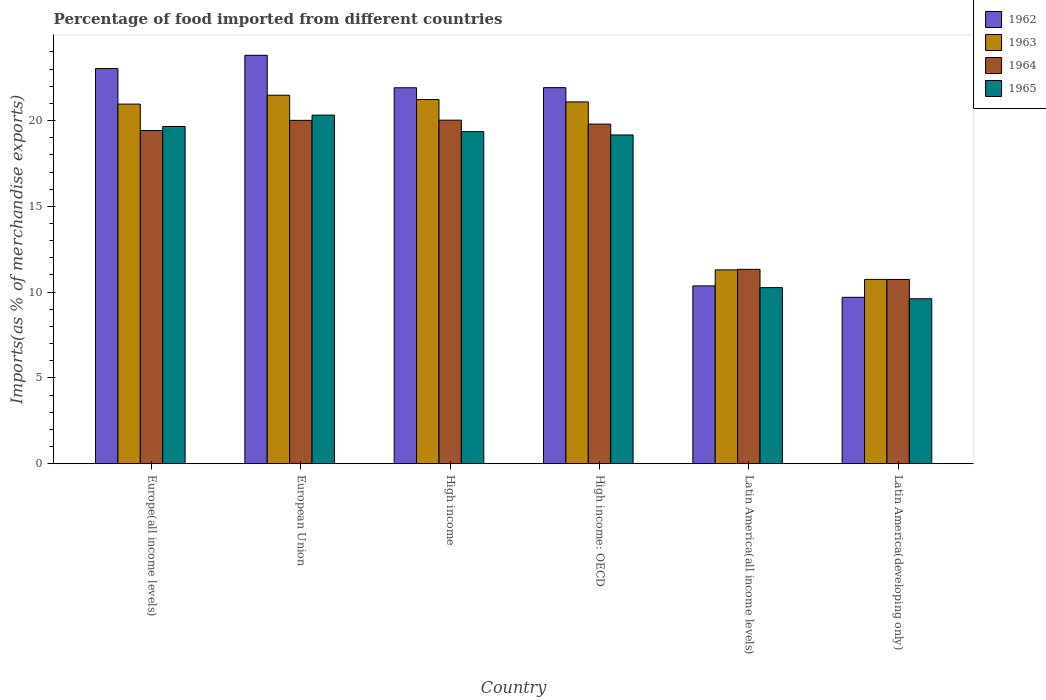How many different coloured bars are there?
Give a very brief answer. 4. How many groups of bars are there?
Offer a terse response. 6. Are the number of bars per tick equal to the number of legend labels?
Your response must be concise. Yes. How many bars are there on the 6th tick from the right?
Your answer should be compact. 4. What is the label of the 4th group of bars from the left?
Your response must be concise. High income: OECD. In how many cases, is the number of bars for a given country not equal to the number of legend labels?
Your answer should be very brief. 0. What is the percentage of imports to different countries in 1965 in Latin America(developing only)?
Offer a very short reply. 9.62. Across all countries, what is the maximum percentage of imports to different countries in 1964?
Ensure brevity in your answer.  20.02. Across all countries, what is the minimum percentage of imports to different countries in 1962?
Keep it short and to the point. 9.7. In which country was the percentage of imports to different countries in 1965 minimum?
Offer a terse response. Latin America(developing only). What is the total percentage of imports to different countries in 1963 in the graph?
Provide a short and direct response. 106.79. What is the difference between the percentage of imports to different countries in 1962 in High income and that in Latin America(developing only)?
Offer a terse response. 12.21. What is the difference between the percentage of imports to different countries in 1964 in European Union and the percentage of imports to different countries in 1963 in High income?
Provide a succinct answer. -1.21. What is the average percentage of imports to different countries in 1965 per country?
Provide a succinct answer. 16.4. What is the difference between the percentage of imports to different countries of/in 1965 and percentage of imports to different countries of/in 1964 in Europe(all income levels)?
Your answer should be compact. 0.24. In how many countries, is the percentage of imports to different countries in 1962 greater than 3 %?
Your answer should be compact. 6. What is the ratio of the percentage of imports to different countries in 1962 in High income to that in High income: OECD?
Keep it short and to the point. 1. Is the difference between the percentage of imports to different countries in 1965 in High income: OECD and Latin America(all income levels) greater than the difference between the percentage of imports to different countries in 1964 in High income: OECD and Latin America(all income levels)?
Give a very brief answer. Yes. What is the difference between the highest and the second highest percentage of imports to different countries in 1965?
Offer a terse response. -0.3. What is the difference between the highest and the lowest percentage of imports to different countries in 1964?
Provide a short and direct response. 9.29. Is the sum of the percentage of imports to different countries in 1965 in European Union and High income greater than the maximum percentage of imports to different countries in 1963 across all countries?
Your answer should be compact. Yes. Is it the case that in every country, the sum of the percentage of imports to different countries in 1963 and percentage of imports to different countries in 1962 is greater than the sum of percentage of imports to different countries in 1965 and percentage of imports to different countries in 1964?
Your response must be concise. No. What does the 1st bar from the left in Latin America(developing only) represents?
Provide a short and direct response. 1962. How many bars are there?
Your answer should be very brief. 24. What is the difference between two consecutive major ticks on the Y-axis?
Ensure brevity in your answer.  5. Are the values on the major ticks of Y-axis written in scientific E-notation?
Offer a very short reply. No. Where does the legend appear in the graph?
Give a very brief answer. Top right. How many legend labels are there?
Your answer should be compact. 4. How are the legend labels stacked?
Offer a very short reply. Vertical. What is the title of the graph?
Your answer should be compact. Percentage of food imported from different countries. Does "1976" appear as one of the legend labels in the graph?
Keep it short and to the point. No. What is the label or title of the X-axis?
Offer a very short reply. Country. What is the label or title of the Y-axis?
Provide a succinct answer. Imports(as % of merchandise exports). What is the Imports(as % of merchandise exports) in 1962 in Europe(all income levels)?
Your answer should be compact. 23.03. What is the Imports(as % of merchandise exports) in 1963 in Europe(all income levels)?
Offer a terse response. 20.96. What is the Imports(as % of merchandise exports) in 1964 in Europe(all income levels)?
Your answer should be compact. 19.42. What is the Imports(as % of merchandise exports) in 1965 in Europe(all income levels)?
Make the answer very short. 19.66. What is the Imports(as % of merchandise exports) of 1962 in European Union?
Provide a succinct answer. 23.8. What is the Imports(as % of merchandise exports) of 1963 in European Union?
Offer a terse response. 21.48. What is the Imports(as % of merchandise exports) in 1964 in European Union?
Provide a succinct answer. 20.01. What is the Imports(as % of merchandise exports) in 1965 in European Union?
Make the answer very short. 20.32. What is the Imports(as % of merchandise exports) of 1962 in High income?
Keep it short and to the point. 21.91. What is the Imports(as % of merchandise exports) in 1963 in High income?
Ensure brevity in your answer.  21.23. What is the Imports(as % of merchandise exports) in 1964 in High income?
Provide a succinct answer. 20.02. What is the Imports(as % of merchandise exports) of 1965 in High income?
Make the answer very short. 19.36. What is the Imports(as % of merchandise exports) of 1962 in High income: OECD?
Offer a very short reply. 21.92. What is the Imports(as % of merchandise exports) of 1963 in High income: OECD?
Ensure brevity in your answer.  21.09. What is the Imports(as % of merchandise exports) in 1964 in High income: OECD?
Make the answer very short. 19.8. What is the Imports(as % of merchandise exports) of 1965 in High income: OECD?
Ensure brevity in your answer.  19.16. What is the Imports(as % of merchandise exports) in 1962 in Latin America(all income levels)?
Provide a succinct answer. 10.36. What is the Imports(as % of merchandise exports) in 1963 in Latin America(all income levels)?
Provide a succinct answer. 11.3. What is the Imports(as % of merchandise exports) of 1964 in Latin America(all income levels)?
Ensure brevity in your answer.  11.33. What is the Imports(as % of merchandise exports) in 1965 in Latin America(all income levels)?
Offer a very short reply. 10.26. What is the Imports(as % of merchandise exports) of 1962 in Latin America(developing only)?
Offer a very short reply. 9.7. What is the Imports(as % of merchandise exports) in 1963 in Latin America(developing only)?
Keep it short and to the point. 10.74. What is the Imports(as % of merchandise exports) of 1964 in Latin America(developing only)?
Make the answer very short. 10.74. What is the Imports(as % of merchandise exports) in 1965 in Latin America(developing only)?
Ensure brevity in your answer.  9.62. Across all countries, what is the maximum Imports(as % of merchandise exports) in 1962?
Your answer should be very brief. 23.8. Across all countries, what is the maximum Imports(as % of merchandise exports) in 1963?
Your answer should be compact. 21.48. Across all countries, what is the maximum Imports(as % of merchandise exports) of 1964?
Your answer should be very brief. 20.02. Across all countries, what is the maximum Imports(as % of merchandise exports) in 1965?
Provide a succinct answer. 20.32. Across all countries, what is the minimum Imports(as % of merchandise exports) of 1962?
Provide a succinct answer. 9.7. Across all countries, what is the minimum Imports(as % of merchandise exports) in 1963?
Offer a very short reply. 10.74. Across all countries, what is the minimum Imports(as % of merchandise exports) in 1964?
Keep it short and to the point. 10.74. Across all countries, what is the minimum Imports(as % of merchandise exports) of 1965?
Offer a terse response. 9.62. What is the total Imports(as % of merchandise exports) in 1962 in the graph?
Ensure brevity in your answer.  110.73. What is the total Imports(as % of merchandise exports) in 1963 in the graph?
Offer a very short reply. 106.79. What is the total Imports(as % of merchandise exports) in 1964 in the graph?
Your response must be concise. 101.32. What is the total Imports(as % of merchandise exports) in 1965 in the graph?
Offer a terse response. 98.37. What is the difference between the Imports(as % of merchandise exports) in 1962 in Europe(all income levels) and that in European Union?
Ensure brevity in your answer.  -0.77. What is the difference between the Imports(as % of merchandise exports) of 1963 in Europe(all income levels) and that in European Union?
Make the answer very short. -0.52. What is the difference between the Imports(as % of merchandise exports) of 1964 in Europe(all income levels) and that in European Union?
Make the answer very short. -0.59. What is the difference between the Imports(as % of merchandise exports) of 1965 in Europe(all income levels) and that in European Union?
Your answer should be very brief. -0.66. What is the difference between the Imports(as % of merchandise exports) in 1962 in Europe(all income levels) and that in High income?
Give a very brief answer. 1.12. What is the difference between the Imports(as % of merchandise exports) in 1963 in Europe(all income levels) and that in High income?
Your answer should be very brief. -0.27. What is the difference between the Imports(as % of merchandise exports) in 1964 in Europe(all income levels) and that in High income?
Offer a terse response. -0.61. What is the difference between the Imports(as % of merchandise exports) in 1965 in Europe(all income levels) and that in High income?
Make the answer very short. 0.3. What is the difference between the Imports(as % of merchandise exports) of 1962 in Europe(all income levels) and that in High income: OECD?
Offer a terse response. 1.11. What is the difference between the Imports(as % of merchandise exports) of 1963 in Europe(all income levels) and that in High income: OECD?
Offer a very short reply. -0.13. What is the difference between the Imports(as % of merchandise exports) of 1964 in Europe(all income levels) and that in High income: OECD?
Offer a terse response. -0.38. What is the difference between the Imports(as % of merchandise exports) in 1965 in Europe(all income levels) and that in High income: OECD?
Ensure brevity in your answer.  0.5. What is the difference between the Imports(as % of merchandise exports) in 1962 in Europe(all income levels) and that in Latin America(all income levels)?
Keep it short and to the point. 12.67. What is the difference between the Imports(as % of merchandise exports) in 1963 in Europe(all income levels) and that in Latin America(all income levels)?
Keep it short and to the point. 9.66. What is the difference between the Imports(as % of merchandise exports) in 1964 in Europe(all income levels) and that in Latin America(all income levels)?
Give a very brief answer. 8.09. What is the difference between the Imports(as % of merchandise exports) of 1965 in Europe(all income levels) and that in Latin America(all income levels)?
Offer a very short reply. 9.39. What is the difference between the Imports(as % of merchandise exports) in 1962 in Europe(all income levels) and that in Latin America(developing only)?
Provide a short and direct response. 13.33. What is the difference between the Imports(as % of merchandise exports) of 1963 in Europe(all income levels) and that in Latin America(developing only)?
Offer a terse response. 10.22. What is the difference between the Imports(as % of merchandise exports) of 1964 in Europe(all income levels) and that in Latin America(developing only)?
Give a very brief answer. 8.68. What is the difference between the Imports(as % of merchandise exports) of 1965 in Europe(all income levels) and that in Latin America(developing only)?
Offer a very short reply. 10.04. What is the difference between the Imports(as % of merchandise exports) of 1962 in European Union and that in High income?
Give a very brief answer. 1.89. What is the difference between the Imports(as % of merchandise exports) of 1963 in European Union and that in High income?
Offer a very short reply. 0.25. What is the difference between the Imports(as % of merchandise exports) in 1964 in European Union and that in High income?
Offer a terse response. -0.01. What is the difference between the Imports(as % of merchandise exports) in 1965 in European Union and that in High income?
Offer a terse response. 0.96. What is the difference between the Imports(as % of merchandise exports) in 1962 in European Union and that in High income: OECD?
Provide a succinct answer. 1.89. What is the difference between the Imports(as % of merchandise exports) of 1963 in European Union and that in High income: OECD?
Give a very brief answer. 0.39. What is the difference between the Imports(as % of merchandise exports) in 1964 in European Union and that in High income: OECD?
Provide a short and direct response. 0.22. What is the difference between the Imports(as % of merchandise exports) of 1965 in European Union and that in High income: OECD?
Give a very brief answer. 1.16. What is the difference between the Imports(as % of merchandise exports) in 1962 in European Union and that in Latin America(all income levels)?
Provide a succinct answer. 13.44. What is the difference between the Imports(as % of merchandise exports) of 1963 in European Union and that in Latin America(all income levels)?
Your answer should be compact. 10.18. What is the difference between the Imports(as % of merchandise exports) of 1964 in European Union and that in Latin America(all income levels)?
Keep it short and to the point. 8.68. What is the difference between the Imports(as % of merchandise exports) in 1965 in European Union and that in Latin America(all income levels)?
Provide a succinct answer. 10.05. What is the difference between the Imports(as % of merchandise exports) in 1962 in European Union and that in Latin America(developing only)?
Make the answer very short. 14.11. What is the difference between the Imports(as % of merchandise exports) in 1963 in European Union and that in Latin America(developing only)?
Your answer should be very brief. 10.73. What is the difference between the Imports(as % of merchandise exports) of 1964 in European Union and that in Latin America(developing only)?
Provide a short and direct response. 9.27. What is the difference between the Imports(as % of merchandise exports) in 1965 in European Union and that in Latin America(developing only)?
Your response must be concise. 10.7. What is the difference between the Imports(as % of merchandise exports) of 1962 in High income and that in High income: OECD?
Keep it short and to the point. -0.01. What is the difference between the Imports(as % of merchandise exports) in 1963 in High income and that in High income: OECD?
Your response must be concise. 0.14. What is the difference between the Imports(as % of merchandise exports) in 1964 in High income and that in High income: OECD?
Keep it short and to the point. 0.23. What is the difference between the Imports(as % of merchandise exports) of 1965 in High income and that in High income: OECD?
Make the answer very short. 0.19. What is the difference between the Imports(as % of merchandise exports) in 1962 in High income and that in Latin America(all income levels)?
Ensure brevity in your answer.  11.55. What is the difference between the Imports(as % of merchandise exports) in 1963 in High income and that in Latin America(all income levels)?
Give a very brief answer. 9.93. What is the difference between the Imports(as % of merchandise exports) of 1964 in High income and that in Latin America(all income levels)?
Keep it short and to the point. 8.7. What is the difference between the Imports(as % of merchandise exports) of 1965 in High income and that in Latin America(all income levels)?
Provide a succinct answer. 9.09. What is the difference between the Imports(as % of merchandise exports) in 1962 in High income and that in Latin America(developing only)?
Offer a very short reply. 12.21. What is the difference between the Imports(as % of merchandise exports) in 1963 in High income and that in Latin America(developing only)?
Provide a short and direct response. 10.48. What is the difference between the Imports(as % of merchandise exports) in 1964 in High income and that in Latin America(developing only)?
Offer a very short reply. 9.29. What is the difference between the Imports(as % of merchandise exports) in 1965 in High income and that in Latin America(developing only)?
Your answer should be compact. 9.74. What is the difference between the Imports(as % of merchandise exports) of 1962 in High income: OECD and that in Latin America(all income levels)?
Your response must be concise. 11.55. What is the difference between the Imports(as % of merchandise exports) of 1963 in High income: OECD and that in Latin America(all income levels)?
Offer a terse response. 9.79. What is the difference between the Imports(as % of merchandise exports) in 1964 in High income: OECD and that in Latin America(all income levels)?
Keep it short and to the point. 8.47. What is the difference between the Imports(as % of merchandise exports) in 1965 in High income: OECD and that in Latin America(all income levels)?
Your answer should be very brief. 8.9. What is the difference between the Imports(as % of merchandise exports) in 1962 in High income: OECD and that in Latin America(developing only)?
Make the answer very short. 12.22. What is the difference between the Imports(as % of merchandise exports) in 1963 in High income: OECD and that in Latin America(developing only)?
Your answer should be very brief. 10.34. What is the difference between the Imports(as % of merchandise exports) of 1964 in High income: OECD and that in Latin America(developing only)?
Provide a succinct answer. 9.06. What is the difference between the Imports(as % of merchandise exports) in 1965 in High income: OECD and that in Latin America(developing only)?
Provide a succinct answer. 9.54. What is the difference between the Imports(as % of merchandise exports) of 1962 in Latin America(all income levels) and that in Latin America(developing only)?
Give a very brief answer. 0.67. What is the difference between the Imports(as % of merchandise exports) of 1963 in Latin America(all income levels) and that in Latin America(developing only)?
Provide a short and direct response. 0.56. What is the difference between the Imports(as % of merchandise exports) of 1964 in Latin America(all income levels) and that in Latin America(developing only)?
Ensure brevity in your answer.  0.59. What is the difference between the Imports(as % of merchandise exports) of 1965 in Latin America(all income levels) and that in Latin America(developing only)?
Your response must be concise. 0.65. What is the difference between the Imports(as % of merchandise exports) in 1962 in Europe(all income levels) and the Imports(as % of merchandise exports) in 1963 in European Union?
Give a very brief answer. 1.55. What is the difference between the Imports(as % of merchandise exports) in 1962 in Europe(all income levels) and the Imports(as % of merchandise exports) in 1964 in European Union?
Make the answer very short. 3.02. What is the difference between the Imports(as % of merchandise exports) of 1962 in Europe(all income levels) and the Imports(as % of merchandise exports) of 1965 in European Union?
Your answer should be very brief. 2.71. What is the difference between the Imports(as % of merchandise exports) in 1963 in Europe(all income levels) and the Imports(as % of merchandise exports) in 1964 in European Union?
Your answer should be very brief. 0.95. What is the difference between the Imports(as % of merchandise exports) of 1963 in Europe(all income levels) and the Imports(as % of merchandise exports) of 1965 in European Union?
Ensure brevity in your answer.  0.64. What is the difference between the Imports(as % of merchandise exports) in 1964 in Europe(all income levels) and the Imports(as % of merchandise exports) in 1965 in European Union?
Make the answer very short. -0.9. What is the difference between the Imports(as % of merchandise exports) of 1962 in Europe(all income levels) and the Imports(as % of merchandise exports) of 1963 in High income?
Offer a terse response. 1.81. What is the difference between the Imports(as % of merchandise exports) of 1962 in Europe(all income levels) and the Imports(as % of merchandise exports) of 1964 in High income?
Keep it short and to the point. 3.01. What is the difference between the Imports(as % of merchandise exports) of 1962 in Europe(all income levels) and the Imports(as % of merchandise exports) of 1965 in High income?
Provide a short and direct response. 3.68. What is the difference between the Imports(as % of merchandise exports) of 1963 in Europe(all income levels) and the Imports(as % of merchandise exports) of 1964 in High income?
Your response must be concise. 0.94. What is the difference between the Imports(as % of merchandise exports) of 1963 in Europe(all income levels) and the Imports(as % of merchandise exports) of 1965 in High income?
Make the answer very short. 1.61. What is the difference between the Imports(as % of merchandise exports) in 1964 in Europe(all income levels) and the Imports(as % of merchandise exports) in 1965 in High income?
Provide a succinct answer. 0.06. What is the difference between the Imports(as % of merchandise exports) in 1962 in Europe(all income levels) and the Imports(as % of merchandise exports) in 1963 in High income: OECD?
Ensure brevity in your answer.  1.94. What is the difference between the Imports(as % of merchandise exports) of 1962 in Europe(all income levels) and the Imports(as % of merchandise exports) of 1964 in High income: OECD?
Offer a very short reply. 3.24. What is the difference between the Imports(as % of merchandise exports) of 1962 in Europe(all income levels) and the Imports(as % of merchandise exports) of 1965 in High income: OECD?
Give a very brief answer. 3.87. What is the difference between the Imports(as % of merchandise exports) in 1963 in Europe(all income levels) and the Imports(as % of merchandise exports) in 1964 in High income: OECD?
Your answer should be very brief. 1.16. What is the difference between the Imports(as % of merchandise exports) in 1963 in Europe(all income levels) and the Imports(as % of merchandise exports) in 1965 in High income: OECD?
Your answer should be very brief. 1.8. What is the difference between the Imports(as % of merchandise exports) in 1964 in Europe(all income levels) and the Imports(as % of merchandise exports) in 1965 in High income: OECD?
Ensure brevity in your answer.  0.26. What is the difference between the Imports(as % of merchandise exports) in 1962 in Europe(all income levels) and the Imports(as % of merchandise exports) in 1963 in Latin America(all income levels)?
Ensure brevity in your answer.  11.73. What is the difference between the Imports(as % of merchandise exports) in 1962 in Europe(all income levels) and the Imports(as % of merchandise exports) in 1964 in Latin America(all income levels)?
Your answer should be very brief. 11.7. What is the difference between the Imports(as % of merchandise exports) of 1962 in Europe(all income levels) and the Imports(as % of merchandise exports) of 1965 in Latin America(all income levels)?
Provide a succinct answer. 12.77. What is the difference between the Imports(as % of merchandise exports) in 1963 in Europe(all income levels) and the Imports(as % of merchandise exports) in 1964 in Latin America(all income levels)?
Provide a succinct answer. 9.63. What is the difference between the Imports(as % of merchandise exports) in 1963 in Europe(all income levels) and the Imports(as % of merchandise exports) in 1965 in Latin America(all income levels)?
Give a very brief answer. 10.7. What is the difference between the Imports(as % of merchandise exports) in 1964 in Europe(all income levels) and the Imports(as % of merchandise exports) in 1965 in Latin America(all income levels)?
Your response must be concise. 9.15. What is the difference between the Imports(as % of merchandise exports) in 1962 in Europe(all income levels) and the Imports(as % of merchandise exports) in 1963 in Latin America(developing only)?
Offer a very short reply. 12.29. What is the difference between the Imports(as % of merchandise exports) of 1962 in Europe(all income levels) and the Imports(as % of merchandise exports) of 1964 in Latin America(developing only)?
Provide a short and direct response. 12.29. What is the difference between the Imports(as % of merchandise exports) in 1962 in Europe(all income levels) and the Imports(as % of merchandise exports) in 1965 in Latin America(developing only)?
Your answer should be compact. 13.41. What is the difference between the Imports(as % of merchandise exports) of 1963 in Europe(all income levels) and the Imports(as % of merchandise exports) of 1964 in Latin America(developing only)?
Offer a terse response. 10.22. What is the difference between the Imports(as % of merchandise exports) in 1963 in Europe(all income levels) and the Imports(as % of merchandise exports) in 1965 in Latin America(developing only)?
Your answer should be very brief. 11.34. What is the difference between the Imports(as % of merchandise exports) of 1964 in Europe(all income levels) and the Imports(as % of merchandise exports) of 1965 in Latin America(developing only)?
Your response must be concise. 9.8. What is the difference between the Imports(as % of merchandise exports) in 1962 in European Union and the Imports(as % of merchandise exports) in 1963 in High income?
Your answer should be compact. 2.58. What is the difference between the Imports(as % of merchandise exports) of 1962 in European Union and the Imports(as % of merchandise exports) of 1964 in High income?
Offer a terse response. 3.78. What is the difference between the Imports(as % of merchandise exports) of 1962 in European Union and the Imports(as % of merchandise exports) of 1965 in High income?
Offer a very short reply. 4.45. What is the difference between the Imports(as % of merchandise exports) in 1963 in European Union and the Imports(as % of merchandise exports) in 1964 in High income?
Your response must be concise. 1.45. What is the difference between the Imports(as % of merchandise exports) of 1963 in European Union and the Imports(as % of merchandise exports) of 1965 in High income?
Offer a very short reply. 2.12. What is the difference between the Imports(as % of merchandise exports) of 1964 in European Union and the Imports(as % of merchandise exports) of 1965 in High income?
Offer a very short reply. 0.66. What is the difference between the Imports(as % of merchandise exports) in 1962 in European Union and the Imports(as % of merchandise exports) in 1963 in High income: OECD?
Your answer should be compact. 2.72. What is the difference between the Imports(as % of merchandise exports) of 1962 in European Union and the Imports(as % of merchandise exports) of 1964 in High income: OECD?
Offer a terse response. 4.01. What is the difference between the Imports(as % of merchandise exports) in 1962 in European Union and the Imports(as % of merchandise exports) in 1965 in High income: OECD?
Provide a short and direct response. 4.64. What is the difference between the Imports(as % of merchandise exports) of 1963 in European Union and the Imports(as % of merchandise exports) of 1964 in High income: OECD?
Offer a very short reply. 1.68. What is the difference between the Imports(as % of merchandise exports) of 1963 in European Union and the Imports(as % of merchandise exports) of 1965 in High income: OECD?
Provide a succinct answer. 2.32. What is the difference between the Imports(as % of merchandise exports) of 1964 in European Union and the Imports(as % of merchandise exports) of 1965 in High income: OECD?
Your response must be concise. 0.85. What is the difference between the Imports(as % of merchandise exports) of 1962 in European Union and the Imports(as % of merchandise exports) of 1963 in Latin America(all income levels)?
Ensure brevity in your answer.  12.51. What is the difference between the Imports(as % of merchandise exports) in 1962 in European Union and the Imports(as % of merchandise exports) in 1964 in Latin America(all income levels)?
Provide a succinct answer. 12.47. What is the difference between the Imports(as % of merchandise exports) in 1962 in European Union and the Imports(as % of merchandise exports) in 1965 in Latin America(all income levels)?
Your answer should be compact. 13.54. What is the difference between the Imports(as % of merchandise exports) of 1963 in European Union and the Imports(as % of merchandise exports) of 1964 in Latin America(all income levels)?
Keep it short and to the point. 10.15. What is the difference between the Imports(as % of merchandise exports) in 1963 in European Union and the Imports(as % of merchandise exports) in 1965 in Latin America(all income levels)?
Your response must be concise. 11.21. What is the difference between the Imports(as % of merchandise exports) in 1964 in European Union and the Imports(as % of merchandise exports) in 1965 in Latin America(all income levels)?
Offer a terse response. 9.75. What is the difference between the Imports(as % of merchandise exports) of 1962 in European Union and the Imports(as % of merchandise exports) of 1963 in Latin America(developing only)?
Make the answer very short. 13.06. What is the difference between the Imports(as % of merchandise exports) of 1962 in European Union and the Imports(as % of merchandise exports) of 1964 in Latin America(developing only)?
Keep it short and to the point. 13.06. What is the difference between the Imports(as % of merchandise exports) in 1962 in European Union and the Imports(as % of merchandise exports) in 1965 in Latin America(developing only)?
Make the answer very short. 14.19. What is the difference between the Imports(as % of merchandise exports) in 1963 in European Union and the Imports(as % of merchandise exports) in 1964 in Latin America(developing only)?
Your answer should be very brief. 10.74. What is the difference between the Imports(as % of merchandise exports) in 1963 in European Union and the Imports(as % of merchandise exports) in 1965 in Latin America(developing only)?
Your response must be concise. 11.86. What is the difference between the Imports(as % of merchandise exports) in 1964 in European Union and the Imports(as % of merchandise exports) in 1965 in Latin America(developing only)?
Give a very brief answer. 10.39. What is the difference between the Imports(as % of merchandise exports) of 1962 in High income and the Imports(as % of merchandise exports) of 1963 in High income: OECD?
Your answer should be compact. 0.83. What is the difference between the Imports(as % of merchandise exports) in 1962 in High income and the Imports(as % of merchandise exports) in 1964 in High income: OECD?
Ensure brevity in your answer.  2.12. What is the difference between the Imports(as % of merchandise exports) in 1962 in High income and the Imports(as % of merchandise exports) in 1965 in High income: OECD?
Give a very brief answer. 2.75. What is the difference between the Imports(as % of merchandise exports) in 1963 in High income and the Imports(as % of merchandise exports) in 1964 in High income: OECD?
Your answer should be compact. 1.43. What is the difference between the Imports(as % of merchandise exports) of 1963 in High income and the Imports(as % of merchandise exports) of 1965 in High income: OECD?
Your answer should be compact. 2.06. What is the difference between the Imports(as % of merchandise exports) in 1964 in High income and the Imports(as % of merchandise exports) in 1965 in High income: OECD?
Keep it short and to the point. 0.86. What is the difference between the Imports(as % of merchandise exports) of 1962 in High income and the Imports(as % of merchandise exports) of 1963 in Latin America(all income levels)?
Ensure brevity in your answer.  10.61. What is the difference between the Imports(as % of merchandise exports) in 1962 in High income and the Imports(as % of merchandise exports) in 1964 in Latin America(all income levels)?
Keep it short and to the point. 10.58. What is the difference between the Imports(as % of merchandise exports) of 1962 in High income and the Imports(as % of merchandise exports) of 1965 in Latin America(all income levels)?
Ensure brevity in your answer.  11.65. What is the difference between the Imports(as % of merchandise exports) of 1963 in High income and the Imports(as % of merchandise exports) of 1964 in Latin America(all income levels)?
Offer a terse response. 9.9. What is the difference between the Imports(as % of merchandise exports) of 1963 in High income and the Imports(as % of merchandise exports) of 1965 in Latin America(all income levels)?
Provide a succinct answer. 10.96. What is the difference between the Imports(as % of merchandise exports) of 1964 in High income and the Imports(as % of merchandise exports) of 1965 in Latin America(all income levels)?
Provide a short and direct response. 9.76. What is the difference between the Imports(as % of merchandise exports) of 1962 in High income and the Imports(as % of merchandise exports) of 1963 in Latin America(developing only)?
Give a very brief answer. 11.17. What is the difference between the Imports(as % of merchandise exports) in 1962 in High income and the Imports(as % of merchandise exports) in 1964 in Latin America(developing only)?
Your response must be concise. 11.17. What is the difference between the Imports(as % of merchandise exports) of 1962 in High income and the Imports(as % of merchandise exports) of 1965 in Latin America(developing only)?
Offer a terse response. 12.3. What is the difference between the Imports(as % of merchandise exports) in 1963 in High income and the Imports(as % of merchandise exports) in 1964 in Latin America(developing only)?
Provide a succinct answer. 10.49. What is the difference between the Imports(as % of merchandise exports) of 1963 in High income and the Imports(as % of merchandise exports) of 1965 in Latin America(developing only)?
Your answer should be compact. 11.61. What is the difference between the Imports(as % of merchandise exports) of 1964 in High income and the Imports(as % of merchandise exports) of 1965 in Latin America(developing only)?
Give a very brief answer. 10.41. What is the difference between the Imports(as % of merchandise exports) of 1962 in High income: OECD and the Imports(as % of merchandise exports) of 1963 in Latin America(all income levels)?
Keep it short and to the point. 10.62. What is the difference between the Imports(as % of merchandise exports) of 1962 in High income: OECD and the Imports(as % of merchandise exports) of 1964 in Latin America(all income levels)?
Ensure brevity in your answer.  10.59. What is the difference between the Imports(as % of merchandise exports) in 1962 in High income: OECD and the Imports(as % of merchandise exports) in 1965 in Latin America(all income levels)?
Provide a succinct answer. 11.65. What is the difference between the Imports(as % of merchandise exports) in 1963 in High income: OECD and the Imports(as % of merchandise exports) in 1964 in Latin America(all income levels)?
Offer a terse response. 9.76. What is the difference between the Imports(as % of merchandise exports) of 1963 in High income: OECD and the Imports(as % of merchandise exports) of 1965 in Latin America(all income levels)?
Your response must be concise. 10.82. What is the difference between the Imports(as % of merchandise exports) of 1964 in High income: OECD and the Imports(as % of merchandise exports) of 1965 in Latin America(all income levels)?
Offer a very short reply. 9.53. What is the difference between the Imports(as % of merchandise exports) of 1962 in High income: OECD and the Imports(as % of merchandise exports) of 1963 in Latin America(developing only)?
Keep it short and to the point. 11.18. What is the difference between the Imports(as % of merchandise exports) of 1962 in High income: OECD and the Imports(as % of merchandise exports) of 1964 in Latin America(developing only)?
Your answer should be compact. 11.18. What is the difference between the Imports(as % of merchandise exports) in 1962 in High income: OECD and the Imports(as % of merchandise exports) in 1965 in Latin America(developing only)?
Your answer should be very brief. 12.3. What is the difference between the Imports(as % of merchandise exports) in 1963 in High income: OECD and the Imports(as % of merchandise exports) in 1964 in Latin America(developing only)?
Offer a terse response. 10.35. What is the difference between the Imports(as % of merchandise exports) in 1963 in High income: OECD and the Imports(as % of merchandise exports) in 1965 in Latin America(developing only)?
Provide a short and direct response. 11.47. What is the difference between the Imports(as % of merchandise exports) of 1964 in High income: OECD and the Imports(as % of merchandise exports) of 1965 in Latin America(developing only)?
Offer a very short reply. 10.18. What is the difference between the Imports(as % of merchandise exports) of 1962 in Latin America(all income levels) and the Imports(as % of merchandise exports) of 1963 in Latin America(developing only)?
Your answer should be compact. -0.38. What is the difference between the Imports(as % of merchandise exports) of 1962 in Latin America(all income levels) and the Imports(as % of merchandise exports) of 1964 in Latin America(developing only)?
Your answer should be compact. -0.37. What is the difference between the Imports(as % of merchandise exports) in 1962 in Latin America(all income levels) and the Imports(as % of merchandise exports) in 1965 in Latin America(developing only)?
Your answer should be compact. 0.75. What is the difference between the Imports(as % of merchandise exports) in 1963 in Latin America(all income levels) and the Imports(as % of merchandise exports) in 1964 in Latin America(developing only)?
Give a very brief answer. 0.56. What is the difference between the Imports(as % of merchandise exports) of 1963 in Latin America(all income levels) and the Imports(as % of merchandise exports) of 1965 in Latin America(developing only)?
Provide a succinct answer. 1.68. What is the difference between the Imports(as % of merchandise exports) of 1964 in Latin America(all income levels) and the Imports(as % of merchandise exports) of 1965 in Latin America(developing only)?
Give a very brief answer. 1.71. What is the average Imports(as % of merchandise exports) in 1962 per country?
Your answer should be compact. 18.45. What is the average Imports(as % of merchandise exports) in 1963 per country?
Your answer should be very brief. 17.8. What is the average Imports(as % of merchandise exports) of 1964 per country?
Your response must be concise. 16.89. What is the average Imports(as % of merchandise exports) of 1965 per country?
Ensure brevity in your answer.  16.4. What is the difference between the Imports(as % of merchandise exports) of 1962 and Imports(as % of merchandise exports) of 1963 in Europe(all income levels)?
Keep it short and to the point. 2.07. What is the difference between the Imports(as % of merchandise exports) of 1962 and Imports(as % of merchandise exports) of 1964 in Europe(all income levels)?
Offer a terse response. 3.61. What is the difference between the Imports(as % of merchandise exports) in 1962 and Imports(as % of merchandise exports) in 1965 in Europe(all income levels)?
Your answer should be very brief. 3.37. What is the difference between the Imports(as % of merchandise exports) of 1963 and Imports(as % of merchandise exports) of 1964 in Europe(all income levels)?
Your response must be concise. 1.54. What is the difference between the Imports(as % of merchandise exports) of 1963 and Imports(as % of merchandise exports) of 1965 in Europe(all income levels)?
Your answer should be very brief. 1.3. What is the difference between the Imports(as % of merchandise exports) in 1964 and Imports(as % of merchandise exports) in 1965 in Europe(all income levels)?
Your answer should be very brief. -0.24. What is the difference between the Imports(as % of merchandise exports) in 1962 and Imports(as % of merchandise exports) in 1963 in European Union?
Give a very brief answer. 2.33. What is the difference between the Imports(as % of merchandise exports) of 1962 and Imports(as % of merchandise exports) of 1964 in European Union?
Your answer should be very brief. 3.79. What is the difference between the Imports(as % of merchandise exports) in 1962 and Imports(as % of merchandise exports) in 1965 in European Union?
Provide a short and direct response. 3.49. What is the difference between the Imports(as % of merchandise exports) of 1963 and Imports(as % of merchandise exports) of 1964 in European Union?
Ensure brevity in your answer.  1.46. What is the difference between the Imports(as % of merchandise exports) in 1963 and Imports(as % of merchandise exports) in 1965 in European Union?
Make the answer very short. 1.16. What is the difference between the Imports(as % of merchandise exports) in 1964 and Imports(as % of merchandise exports) in 1965 in European Union?
Offer a very short reply. -0.31. What is the difference between the Imports(as % of merchandise exports) of 1962 and Imports(as % of merchandise exports) of 1963 in High income?
Your answer should be very brief. 0.69. What is the difference between the Imports(as % of merchandise exports) in 1962 and Imports(as % of merchandise exports) in 1964 in High income?
Provide a succinct answer. 1.89. What is the difference between the Imports(as % of merchandise exports) in 1962 and Imports(as % of merchandise exports) in 1965 in High income?
Offer a very short reply. 2.56. What is the difference between the Imports(as % of merchandise exports) in 1963 and Imports(as % of merchandise exports) in 1964 in High income?
Give a very brief answer. 1.2. What is the difference between the Imports(as % of merchandise exports) in 1963 and Imports(as % of merchandise exports) in 1965 in High income?
Your response must be concise. 1.87. What is the difference between the Imports(as % of merchandise exports) in 1964 and Imports(as % of merchandise exports) in 1965 in High income?
Your answer should be very brief. 0.67. What is the difference between the Imports(as % of merchandise exports) of 1962 and Imports(as % of merchandise exports) of 1963 in High income: OECD?
Provide a short and direct response. 0.83. What is the difference between the Imports(as % of merchandise exports) in 1962 and Imports(as % of merchandise exports) in 1964 in High income: OECD?
Ensure brevity in your answer.  2.12. What is the difference between the Imports(as % of merchandise exports) in 1962 and Imports(as % of merchandise exports) in 1965 in High income: OECD?
Your answer should be very brief. 2.76. What is the difference between the Imports(as % of merchandise exports) in 1963 and Imports(as % of merchandise exports) in 1964 in High income: OECD?
Make the answer very short. 1.29. What is the difference between the Imports(as % of merchandise exports) in 1963 and Imports(as % of merchandise exports) in 1965 in High income: OECD?
Your response must be concise. 1.93. What is the difference between the Imports(as % of merchandise exports) in 1964 and Imports(as % of merchandise exports) in 1965 in High income: OECD?
Your answer should be very brief. 0.63. What is the difference between the Imports(as % of merchandise exports) in 1962 and Imports(as % of merchandise exports) in 1963 in Latin America(all income levels)?
Keep it short and to the point. -0.93. What is the difference between the Imports(as % of merchandise exports) in 1962 and Imports(as % of merchandise exports) in 1964 in Latin America(all income levels)?
Make the answer very short. -0.96. What is the difference between the Imports(as % of merchandise exports) of 1962 and Imports(as % of merchandise exports) of 1965 in Latin America(all income levels)?
Give a very brief answer. 0.1. What is the difference between the Imports(as % of merchandise exports) of 1963 and Imports(as % of merchandise exports) of 1964 in Latin America(all income levels)?
Your answer should be compact. -0.03. What is the difference between the Imports(as % of merchandise exports) of 1963 and Imports(as % of merchandise exports) of 1965 in Latin America(all income levels)?
Your answer should be very brief. 1.03. What is the difference between the Imports(as % of merchandise exports) of 1964 and Imports(as % of merchandise exports) of 1965 in Latin America(all income levels)?
Ensure brevity in your answer.  1.07. What is the difference between the Imports(as % of merchandise exports) in 1962 and Imports(as % of merchandise exports) in 1963 in Latin America(developing only)?
Your response must be concise. -1.05. What is the difference between the Imports(as % of merchandise exports) of 1962 and Imports(as % of merchandise exports) of 1964 in Latin America(developing only)?
Provide a succinct answer. -1.04. What is the difference between the Imports(as % of merchandise exports) in 1962 and Imports(as % of merchandise exports) in 1965 in Latin America(developing only)?
Keep it short and to the point. 0.08. What is the difference between the Imports(as % of merchandise exports) in 1963 and Imports(as % of merchandise exports) in 1964 in Latin America(developing only)?
Your answer should be very brief. 0. What is the difference between the Imports(as % of merchandise exports) in 1963 and Imports(as % of merchandise exports) in 1965 in Latin America(developing only)?
Your response must be concise. 1.13. What is the difference between the Imports(as % of merchandise exports) of 1964 and Imports(as % of merchandise exports) of 1965 in Latin America(developing only)?
Provide a short and direct response. 1.12. What is the ratio of the Imports(as % of merchandise exports) in 1962 in Europe(all income levels) to that in European Union?
Keep it short and to the point. 0.97. What is the ratio of the Imports(as % of merchandise exports) in 1963 in Europe(all income levels) to that in European Union?
Provide a succinct answer. 0.98. What is the ratio of the Imports(as % of merchandise exports) of 1964 in Europe(all income levels) to that in European Union?
Provide a short and direct response. 0.97. What is the ratio of the Imports(as % of merchandise exports) in 1965 in Europe(all income levels) to that in European Union?
Your answer should be compact. 0.97. What is the ratio of the Imports(as % of merchandise exports) in 1962 in Europe(all income levels) to that in High income?
Offer a terse response. 1.05. What is the ratio of the Imports(as % of merchandise exports) in 1963 in Europe(all income levels) to that in High income?
Keep it short and to the point. 0.99. What is the ratio of the Imports(as % of merchandise exports) in 1964 in Europe(all income levels) to that in High income?
Your response must be concise. 0.97. What is the ratio of the Imports(as % of merchandise exports) in 1965 in Europe(all income levels) to that in High income?
Give a very brief answer. 1.02. What is the ratio of the Imports(as % of merchandise exports) in 1962 in Europe(all income levels) to that in High income: OECD?
Your answer should be compact. 1.05. What is the ratio of the Imports(as % of merchandise exports) in 1965 in Europe(all income levels) to that in High income: OECD?
Provide a short and direct response. 1.03. What is the ratio of the Imports(as % of merchandise exports) of 1962 in Europe(all income levels) to that in Latin America(all income levels)?
Your answer should be compact. 2.22. What is the ratio of the Imports(as % of merchandise exports) of 1963 in Europe(all income levels) to that in Latin America(all income levels)?
Give a very brief answer. 1.86. What is the ratio of the Imports(as % of merchandise exports) of 1964 in Europe(all income levels) to that in Latin America(all income levels)?
Your answer should be very brief. 1.71. What is the ratio of the Imports(as % of merchandise exports) in 1965 in Europe(all income levels) to that in Latin America(all income levels)?
Provide a succinct answer. 1.92. What is the ratio of the Imports(as % of merchandise exports) of 1962 in Europe(all income levels) to that in Latin America(developing only)?
Give a very brief answer. 2.37. What is the ratio of the Imports(as % of merchandise exports) in 1963 in Europe(all income levels) to that in Latin America(developing only)?
Offer a very short reply. 1.95. What is the ratio of the Imports(as % of merchandise exports) of 1964 in Europe(all income levels) to that in Latin America(developing only)?
Offer a very short reply. 1.81. What is the ratio of the Imports(as % of merchandise exports) of 1965 in Europe(all income levels) to that in Latin America(developing only)?
Your answer should be very brief. 2.04. What is the ratio of the Imports(as % of merchandise exports) of 1962 in European Union to that in High income?
Provide a succinct answer. 1.09. What is the ratio of the Imports(as % of merchandise exports) of 1963 in European Union to that in High income?
Your answer should be compact. 1.01. What is the ratio of the Imports(as % of merchandise exports) of 1964 in European Union to that in High income?
Your answer should be compact. 1. What is the ratio of the Imports(as % of merchandise exports) in 1965 in European Union to that in High income?
Provide a succinct answer. 1.05. What is the ratio of the Imports(as % of merchandise exports) of 1962 in European Union to that in High income: OECD?
Offer a very short reply. 1.09. What is the ratio of the Imports(as % of merchandise exports) of 1963 in European Union to that in High income: OECD?
Make the answer very short. 1.02. What is the ratio of the Imports(as % of merchandise exports) of 1964 in European Union to that in High income: OECD?
Offer a terse response. 1.01. What is the ratio of the Imports(as % of merchandise exports) in 1965 in European Union to that in High income: OECD?
Your response must be concise. 1.06. What is the ratio of the Imports(as % of merchandise exports) of 1962 in European Union to that in Latin America(all income levels)?
Make the answer very short. 2.3. What is the ratio of the Imports(as % of merchandise exports) in 1963 in European Union to that in Latin America(all income levels)?
Provide a succinct answer. 1.9. What is the ratio of the Imports(as % of merchandise exports) of 1964 in European Union to that in Latin America(all income levels)?
Make the answer very short. 1.77. What is the ratio of the Imports(as % of merchandise exports) of 1965 in European Union to that in Latin America(all income levels)?
Keep it short and to the point. 1.98. What is the ratio of the Imports(as % of merchandise exports) in 1962 in European Union to that in Latin America(developing only)?
Your response must be concise. 2.45. What is the ratio of the Imports(as % of merchandise exports) of 1963 in European Union to that in Latin America(developing only)?
Your answer should be compact. 2. What is the ratio of the Imports(as % of merchandise exports) in 1964 in European Union to that in Latin America(developing only)?
Offer a terse response. 1.86. What is the ratio of the Imports(as % of merchandise exports) of 1965 in European Union to that in Latin America(developing only)?
Keep it short and to the point. 2.11. What is the ratio of the Imports(as % of merchandise exports) of 1962 in High income to that in High income: OECD?
Give a very brief answer. 1. What is the ratio of the Imports(as % of merchandise exports) of 1963 in High income to that in High income: OECD?
Make the answer very short. 1.01. What is the ratio of the Imports(as % of merchandise exports) in 1964 in High income to that in High income: OECD?
Your answer should be compact. 1.01. What is the ratio of the Imports(as % of merchandise exports) of 1965 in High income to that in High income: OECD?
Your answer should be very brief. 1.01. What is the ratio of the Imports(as % of merchandise exports) of 1962 in High income to that in Latin America(all income levels)?
Give a very brief answer. 2.11. What is the ratio of the Imports(as % of merchandise exports) in 1963 in High income to that in Latin America(all income levels)?
Offer a very short reply. 1.88. What is the ratio of the Imports(as % of merchandise exports) in 1964 in High income to that in Latin America(all income levels)?
Ensure brevity in your answer.  1.77. What is the ratio of the Imports(as % of merchandise exports) in 1965 in High income to that in Latin America(all income levels)?
Keep it short and to the point. 1.89. What is the ratio of the Imports(as % of merchandise exports) in 1962 in High income to that in Latin America(developing only)?
Your response must be concise. 2.26. What is the ratio of the Imports(as % of merchandise exports) in 1963 in High income to that in Latin America(developing only)?
Make the answer very short. 1.98. What is the ratio of the Imports(as % of merchandise exports) in 1964 in High income to that in Latin America(developing only)?
Make the answer very short. 1.86. What is the ratio of the Imports(as % of merchandise exports) of 1965 in High income to that in Latin America(developing only)?
Ensure brevity in your answer.  2.01. What is the ratio of the Imports(as % of merchandise exports) of 1962 in High income: OECD to that in Latin America(all income levels)?
Offer a very short reply. 2.11. What is the ratio of the Imports(as % of merchandise exports) of 1963 in High income: OECD to that in Latin America(all income levels)?
Give a very brief answer. 1.87. What is the ratio of the Imports(as % of merchandise exports) in 1964 in High income: OECD to that in Latin America(all income levels)?
Provide a succinct answer. 1.75. What is the ratio of the Imports(as % of merchandise exports) in 1965 in High income: OECD to that in Latin America(all income levels)?
Keep it short and to the point. 1.87. What is the ratio of the Imports(as % of merchandise exports) of 1962 in High income: OECD to that in Latin America(developing only)?
Keep it short and to the point. 2.26. What is the ratio of the Imports(as % of merchandise exports) of 1963 in High income: OECD to that in Latin America(developing only)?
Make the answer very short. 1.96. What is the ratio of the Imports(as % of merchandise exports) of 1964 in High income: OECD to that in Latin America(developing only)?
Keep it short and to the point. 1.84. What is the ratio of the Imports(as % of merchandise exports) in 1965 in High income: OECD to that in Latin America(developing only)?
Provide a succinct answer. 1.99. What is the ratio of the Imports(as % of merchandise exports) in 1962 in Latin America(all income levels) to that in Latin America(developing only)?
Give a very brief answer. 1.07. What is the ratio of the Imports(as % of merchandise exports) in 1963 in Latin America(all income levels) to that in Latin America(developing only)?
Offer a very short reply. 1.05. What is the ratio of the Imports(as % of merchandise exports) in 1964 in Latin America(all income levels) to that in Latin America(developing only)?
Give a very brief answer. 1.05. What is the ratio of the Imports(as % of merchandise exports) in 1965 in Latin America(all income levels) to that in Latin America(developing only)?
Offer a very short reply. 1.07. What is the difference between the highest and the second highest Imports(as % of merchandise exports) in 1962?
Your answer should be very brief. 0.77. What is the difference between the highest and the second highest Imports(as % of merchandise exports) of 1963?
Provide a succinct answer. 0.25. What is the difference between the highest and the second highest Imports(as % of merchandise exports) of 1964?
Your answer should be very brief. 0.01. What is the difference between the highest and the second highest Imports(as % of merchandise exports) of 1965?
Make the answer very short. 0.66. What is the difference between the highest and the lowest Imports(as % of merchandise exports) in 1962?
Provide a short and direct response. 14.11. What is the difference between the highest and the lowest Imports(as % of merchandise exports) in 1963?
Provide a short and direct response. 10.73. What is the difference between the highest and the lowest Imports(as % of merchandise exports) of 1964?
Keep it short and to the point. 9.29. What is the difference between the highest and the lowest Imports(as % of merchandise exports) of 1965?
Provide a short and direct response. 10.7. 